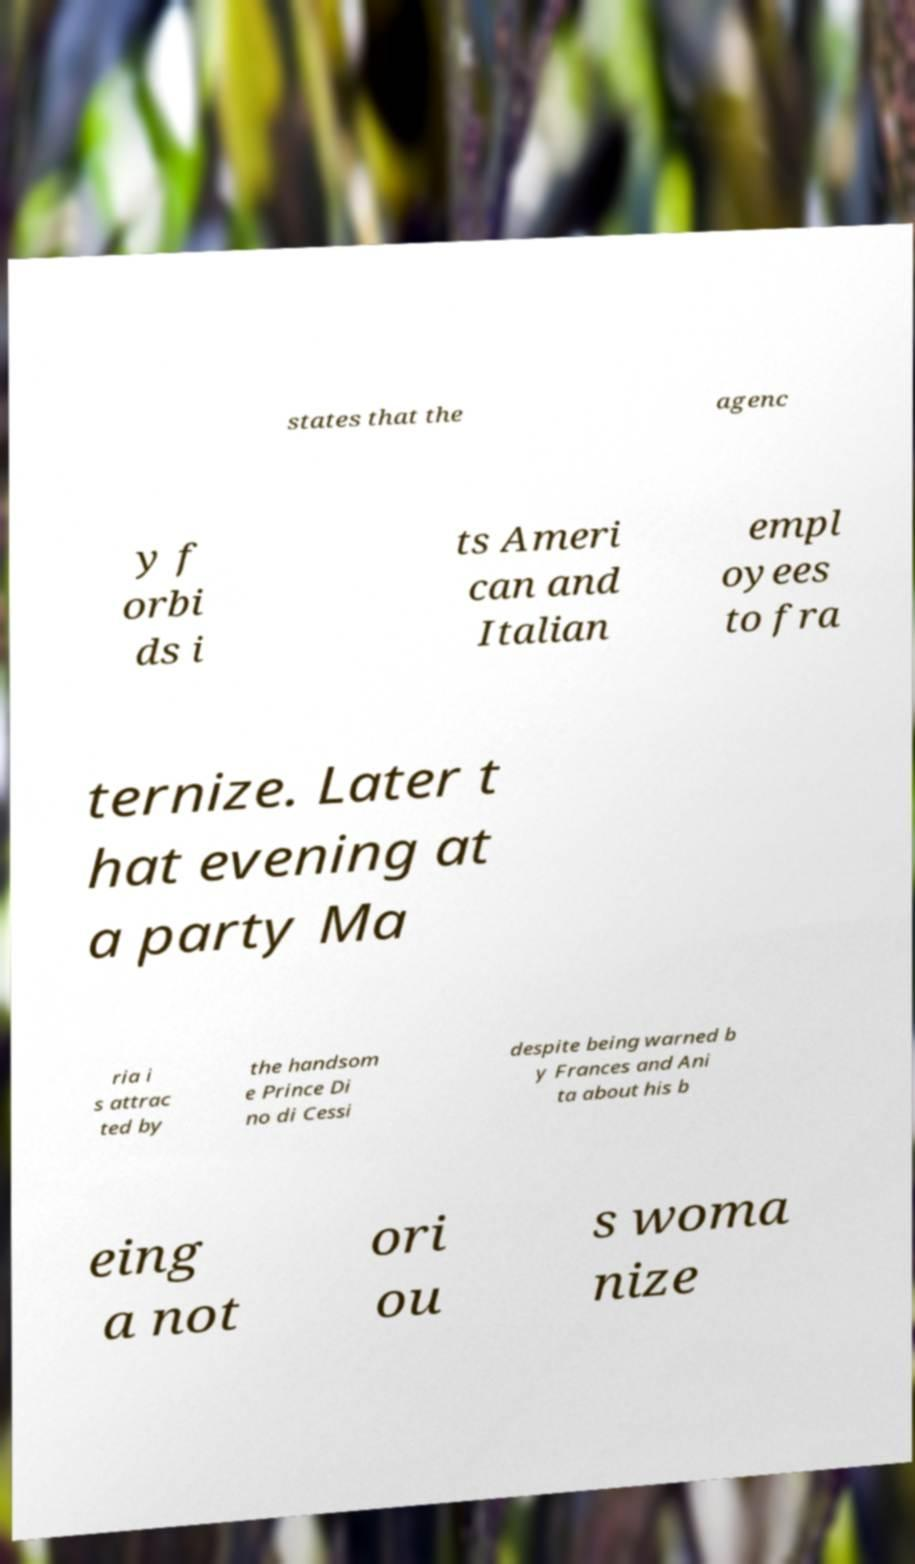Could you extract and type out the text from this image? states that the agenc y f orbi ds i ts Ameri can and Italian empl oyees to fra ternize. Later t hat evening at a party Ma ria i s attrac ted by the handsom e Prince Di no di Cessi despite being warned b y Frances and Ani ta about his b eing a not ori ou s woma nize 